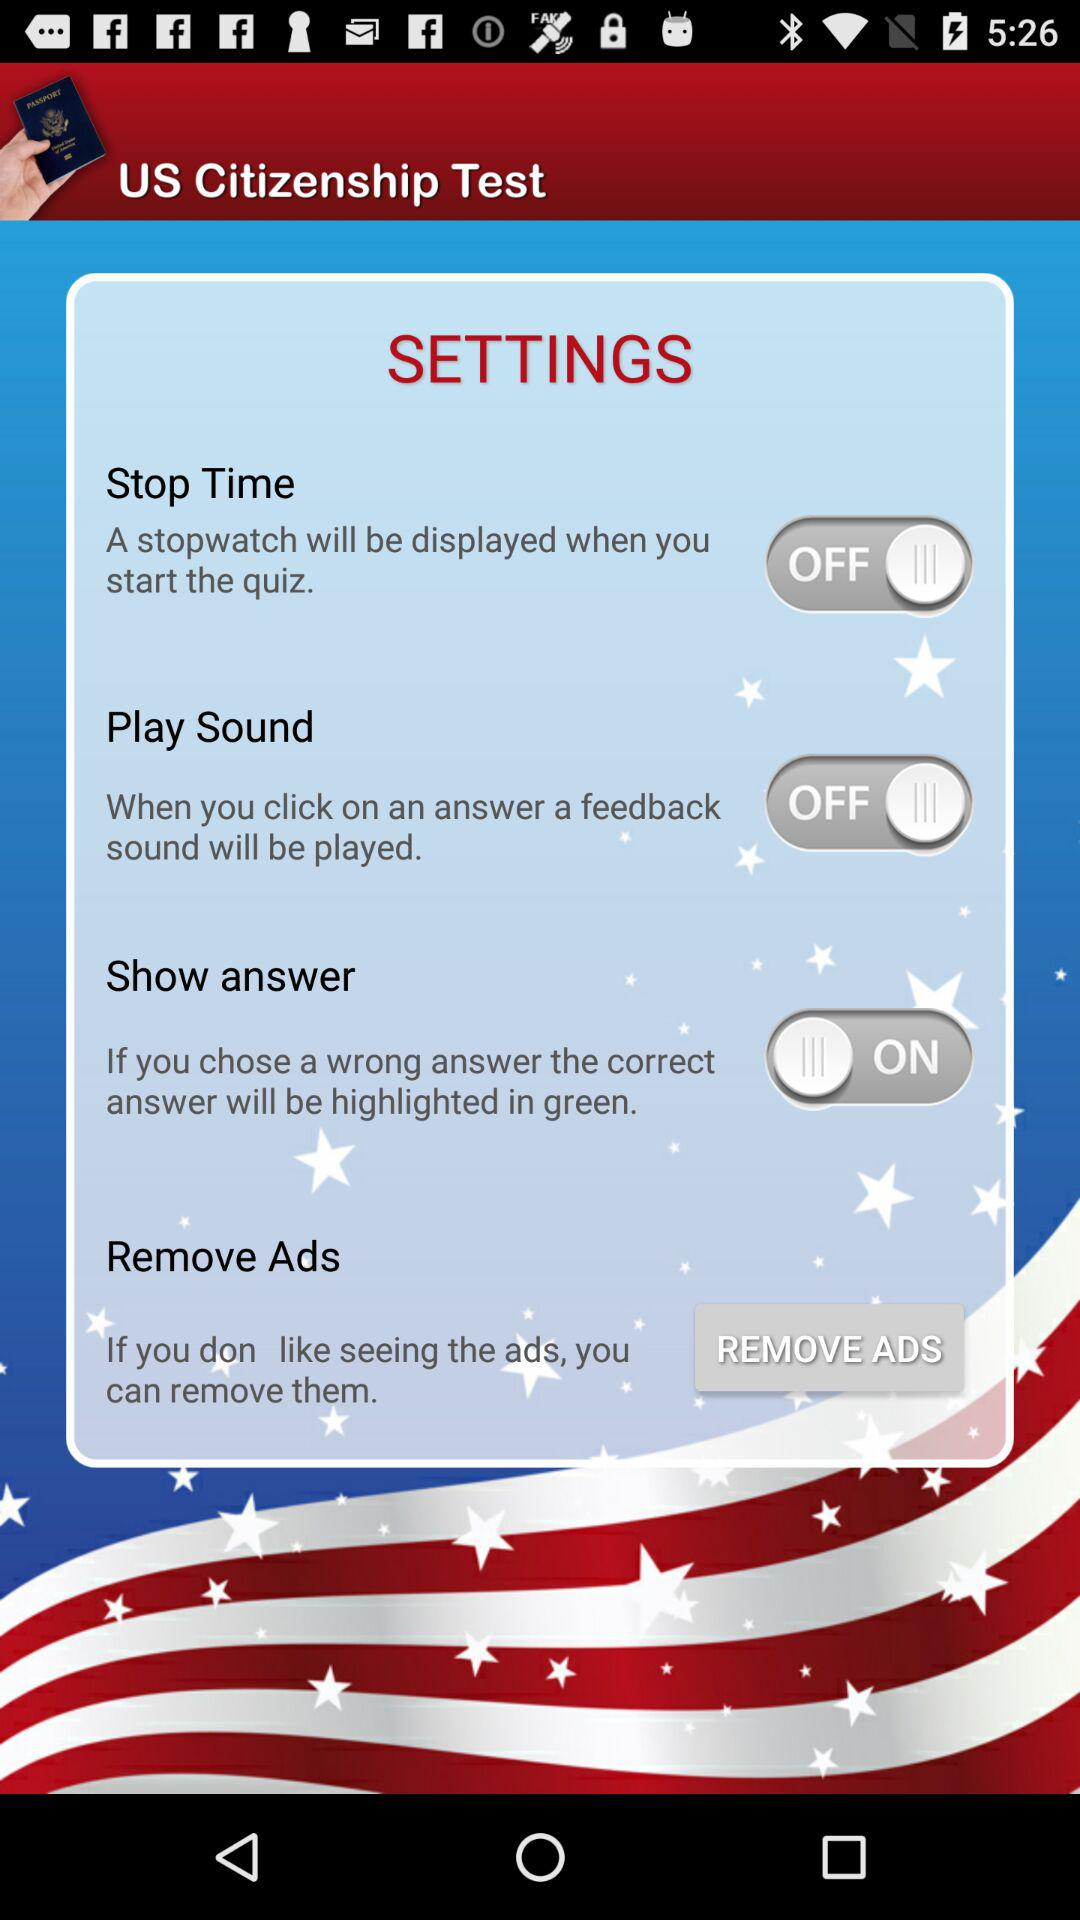What is the status of "Show answer"? The status is "on". 